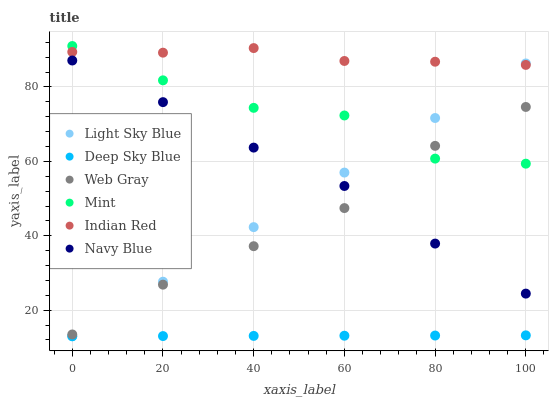Does Deep Sky Blue have the minimum area under the curve?
Answer yes or no. Yes. Does Indian Red have the maximum area under the curve?
Answer yes or no. Yes. Does Navy Blue have the minimum area under the curve?
Answer yes or no. No. Does Navy Blue have the maximum area under the curve?
Answer yes or no. No. Is Deep Sky Blue the smoothest?
Answer yes or no. Yes. Is Mint the roughest?
Answer yes or no. Yes. Is Navy Blue the smoothest?
Answer yes or no. No. Is Navy Blue the roughest?
Answer yes or no. No. Does Deep Sky Blue have the lowest value?
Answer yes or no. Yes. Does Navy Blue have the lowest value?
Answer yes or no. No. Does Mint have the highest value?
Answer yes or no. Yes. Does Navy Blue have the highest value?
Answer yes or no. No. Is Deep Sky Blue less than Navy Blue?
Answer yes or no. Yes. Is Indian Red greater than Navy Blue?
Answer yes or no. Yes. Does Indian Red intersect Light Sky Blue?
Answer yes or no. Yes. Is Indian Red less than Light Sky Blue?
Answer yes or no. No. Is Indian Red greater than Light Sky Blue?
Answer yes or no. No. Does Deep Sky Blue intersect Navy Blue?
Answer yes or no. No. 